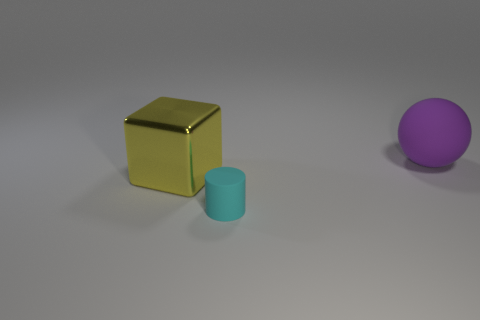There is a rubber object left of the sphere; is it the same size as the matte ball?
Offer a terse response. No. How many objects are either matte objects that are in front of the large yellow metal cube or rubber things in front of the metallic cube?
Provide a short and direct response. 1. There is a object in front of the big yellow metallic object; is its color the same as the sphere?
Your answer should be very brief. No. What number of rubber things are things or large yellow objects?
Your answer should be very brief. 2. What shape is the tiny cyan thing?
Make the answer very short. Cylinder. Is there any other thing that is made of the same material as the large purple ball?
Make the answer very short. Yes. Is the cyan cylinder made of the same material as the cube?
Provide a short and direct response. No. There is a thing that is behind the big thing that is on the left side of the purple rubber ball; are there any cyan cylinders that are in front of it?
Keep it short and to the point. Yes. How many other things are there of the same shape as the yellow thing?
Your answer should be very brief. 0. There is a thing that is both on the right side of the big cube and behind the cylinder; what shape is it?
Your answer should be compact. Sphere. 